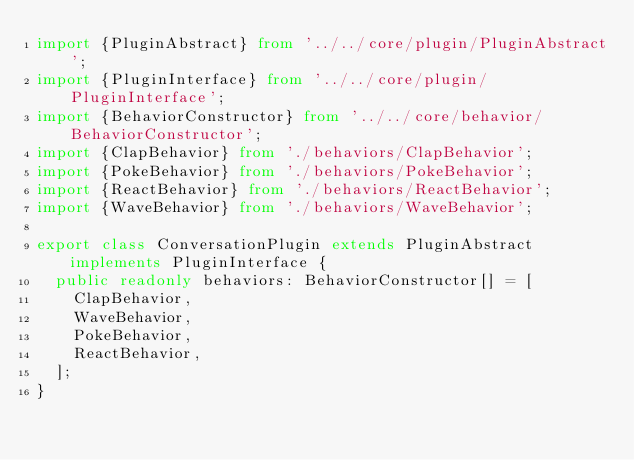Convert code to text. <code><loc_0><loc_0><loc_500><loc_500><_TypeScript_>import {PluginAbstract} from '../../core/plugin/PluginAbstract';
import {PluginInterface} from '../../core/plugin/PluginInterface';
import {BehaviorConstructor} from '../../core/behavior/BehaviorConstructor';
import {ClapBehavior} from './behaviors/ClapBehavior';
import {PokeBehavior} from './behaviors/PokeBehavior';
import {ReactBehavior} from './behaviors/ReactBehavior';
import {WaveBehavior} from './behaviors/WaveBehavior';

export class ConversationPlugin extends PluginAbstract implements PluginInterface {
	public readonly behaviors: BehaviorConstructor[] = [
		ClapBehavior,
		WaveBehavior,
		PokeBehavior,
		ReactBehavior,
	];
}
</code> 